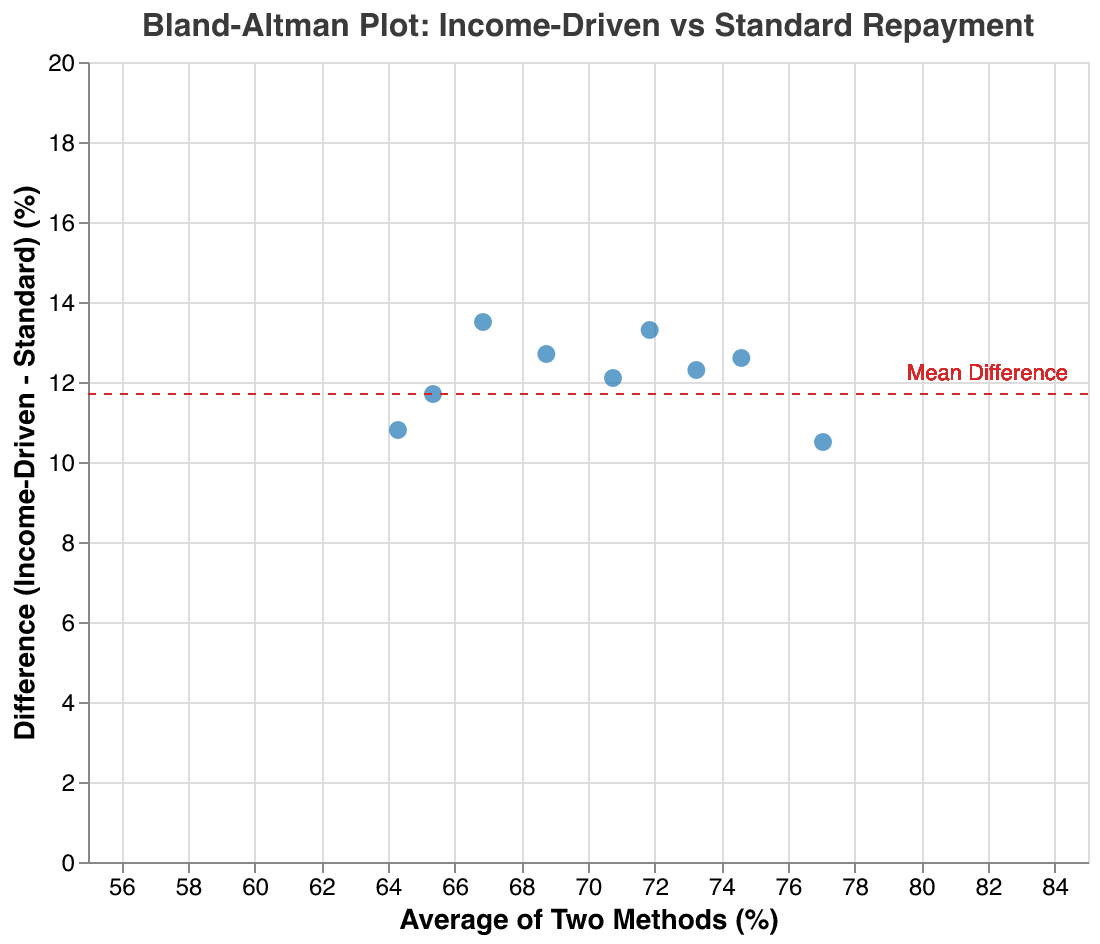What is the title of the figure? The title is located at the top of the figure and reads "Bland-Altman Plot: Income-Driven vs Standard Repayment".
Answer: Bland-Altman Plot: Income-Driven vs Standard Repayment How many data points are plotted in the figure? The plot data includes nine points, each representing a different repayment method.
Answer: Nine What is represented on the x-axis and y-axis? The x-axis shows the "Average of Two Methods (%)", and the y-axis shows the "Difference (Income-Driven - Standard) (%)".
Answer: Average of Two Methods (%) and Difference (Income-Driven - Standard) (%) What does the horizontal red dashed line signify in the plot? A horizontal line indicates the mean difference value for all the data points on the plot, which is set at 11.7 on the y-axis.
Answer: Mean Difference Which method has the highest difference between income-driven and standard repayment rates? By examining the vertical positions of the points, the method with the highest difference is "Perkins Loans" with a difference of 10.5%.
Answer: Perkins Loans What are the approximate average repayment rates for "Federal Direct Loans"? For "Federal Direct Loans," the x-axis value will give the average: (78.5 + 65.2) / 2 = 71.85%.
Answer: 71.85% Is there any method with a difference of less than 10% between the repayment plans? If so, name one. Comparing the y-axis values, "PLUS Loans" show a difference of 10.8%, and "Grad PLUS Loans" show a difference of 12.7%; however, "State-based Loans" show a difference of 12.1%, thereby having a difference near to 10%.
Answer: PLUS Loans How does the average repayment rate (x-axis) for "Stafford Loans" compare to that for "Grad PLUS Loans"? The average repayment rate for "Grad PLUS Loans" is (75.1 + 62.4) / 2 = 68.75%, and for "Stafford Loans," it is (80.9 + 68.3) / 2 = 74.6%. Therefore, "Stafford Loans" have a higher average repayment rate.
Answer: Stafford Loans have a higher average Are all income-driven repayment methods showing better repayment rates than standard repayment methods? By exploring the average repayment differences plotted on the y-axis, all data points lie above the zero line, indicating that income-driven repayment methods always show better repayment rates than standard methods.
Answer: Yes What is the calculated mean difference of repayment rates, and how does it compare to the mean of differences visualized on the plot? The mean difference line is plotted at 11.7%, denoted by a red dashed line. Actual differences are mostly close but vary. This line effectively represents the center trend of the differences presented.
Answer: 11.7% 